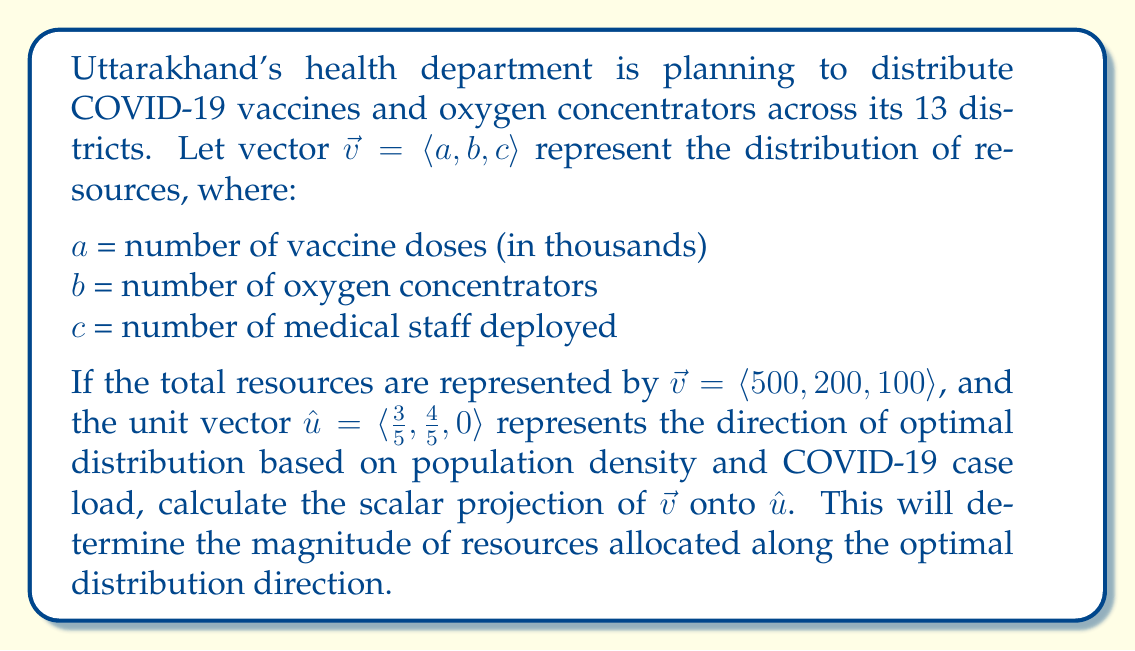Teach me how to tackle this problem. To solve this problem, we'll use the formula for scalar projection:

$$ \text{proj}_{\hat{u}}\vec{v} = \vec{v} \cdot \hat{u} $$

Where $\cdot$ represents the dot product.

Step 1: Calculate the dot product of $\vec{v}$ and $\hat{u}$

$$ \vec{v} \cdot \hat{u} = \langle 500, 200, 100 \rangle \cdot \langle \frac{3}{5}, \frac{4}{5}, 0 \rangle $$

$$ = (500 \cdot \frac{3}{5}) + (200 \cdot \frac{4}{5}) + (100 \cdot 0) $$

$$ = 300 + 160 + 0 = 460 $$

Step 2: The result of the dot product is the scalar projection

Since $\hat{u}$ is a unit vector (magnitude = 1), we don't need to divide by its magnitude. The scalar projection is directly equal to the dot product.

$$ \text{proj}_{\hat{u}}\vec{v} = 460 $$

This means that along the optimal distribution direction, the magnitude of resources allocated is 460 units.

To interpret this result:
- The projection represents the effective allocation of resources in the most needed direction.
- A higher value indicates a better alignment of resource distribution with the optimal direction based on population density and COVID-19 case load.
- The remaining magnitude of resources ($\sqrt{500^2 + 200^2 + 100^2} - 460 \approx 252.39$) represents resources that could potentially be reallocated for more efficient distribution.
Answer: The scalar projection of $\vec{v}$ onto $\hat{u}$ is 460 units. 